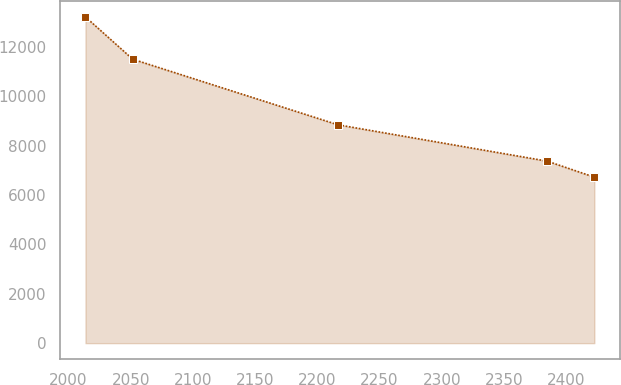<chart> <loc_0><loc_0><loc_500><loc_500><line_chart><ecel><fcel>Unnamed: 1<nl><fcel>2013.69<fcel>13214.4<nl><fcel>2051.65<fcel>11503.8<nl><fcel>2216.62<fcel>8846.25<nl><fcel>2384.73<fcel>7374.35<nl><fcel>2422.69<fcel>6725.46<nl></chart> 